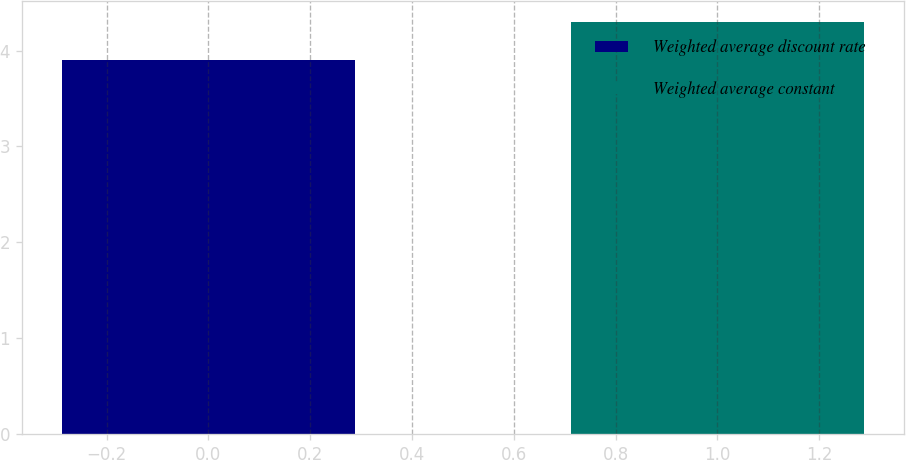Convert chart to OTSL. <chart><loc_0><loc_0><loc_500><loc_500><bar_chart><fcel>Weighted average discount rate<fcel>Weighted average constant<nl><fcel>3.9<fcel>4.3<nl></chart> 